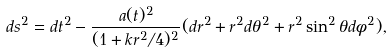Convert formula to latex. <formula><loc_0><loc_0><loc_500><loc_500>d s ^ { 2 } = d t ^ { 2 } - \frac { a ( t ) ^ { 2 } } { ( 1 + k r ^ { 2 } / 4 ) ^ { 2 } } ( d r ^ { 2 } + r ^ { 2 } d \theta ^ { 2 } + r ^ { 2 } \sin ^ { 2 } { \theta } d \phi ^ { 2 } ) ,</formula> 